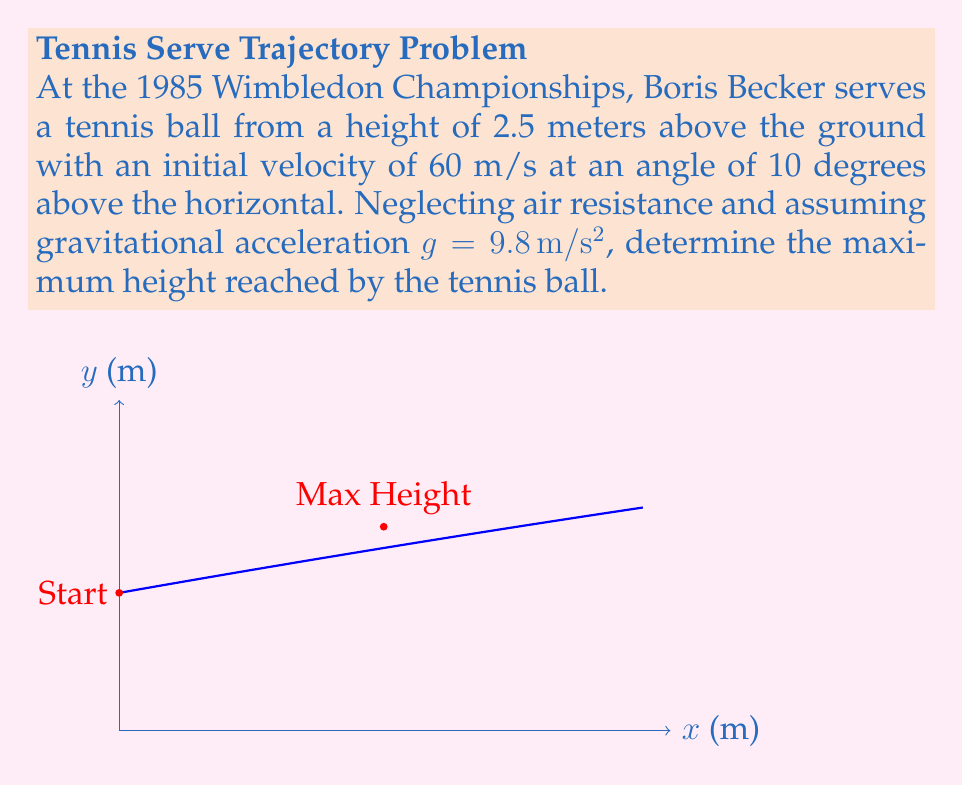What is the answer to this math problem? Let's approach this step-by-step using differential equations:

1) The motion of the tennis ball can be described by two second-order differential equations:

   $$\frac{d^2x}{dt^2} = 0$$
   $$\frac{d^2y}{dt^2} = -g$$

   Where $x$ is the horizontal position, $y$ is the vertical position, $t$ is time, and $g$ is gravitational acceleration.

2) Integrating these equations with respect to time, we get:

   $$\frac{dx}{dt} = v_0 \cos(\theta)$$
   $$\frac{dy}{dt} = v_0 \sin(\theta) - gt$$

   Where $v_0$ is the initial velocity and $\theta$ is the launch angle.

3) Integrating again:

   $$x = v_0 \cos(\theta) t$$
   $$y = 2.5 + v_0 \sin(\theta) t - \frac{1}{2}gt^2$$

4) The maximum height is reached when $\frac{dy}{dt} = 0$:

   $$v_0 \sin(\theta) - gt = 0$$
   $$t = \frac{v_0 \sin(\theta)}{g}$$

5) Substituting this time into the equation for $y$:

   $$y_{max} = 2.5 + v_0 \sin(\theta) (\frac{v_0 \sin(\theta)}{g}) - \frac{1}{2}g(\frac{v_0 \sin(\theta)}{g})^2$$

6) Simplifying:

   $$y_{max} = 2.5 + \frac{v_0^2 \sin^2(\theta)}{2g}$$

7) Now, let's plug in our values:
   $v_0 = 60$ m/s
   $\theta = 10° = 0.1745$ radians
   $g = 9.8$ m/s²

   $$y_{max} = 2.5 + \frac{60^2 \sin^2(0.1745)}{2(9.8)} = 2.5 + 5.22 = 7.72$$

Thus, the maximum height reached by the tennis ball is approximately 7.72 meters.
Answer: 7.72 meters 